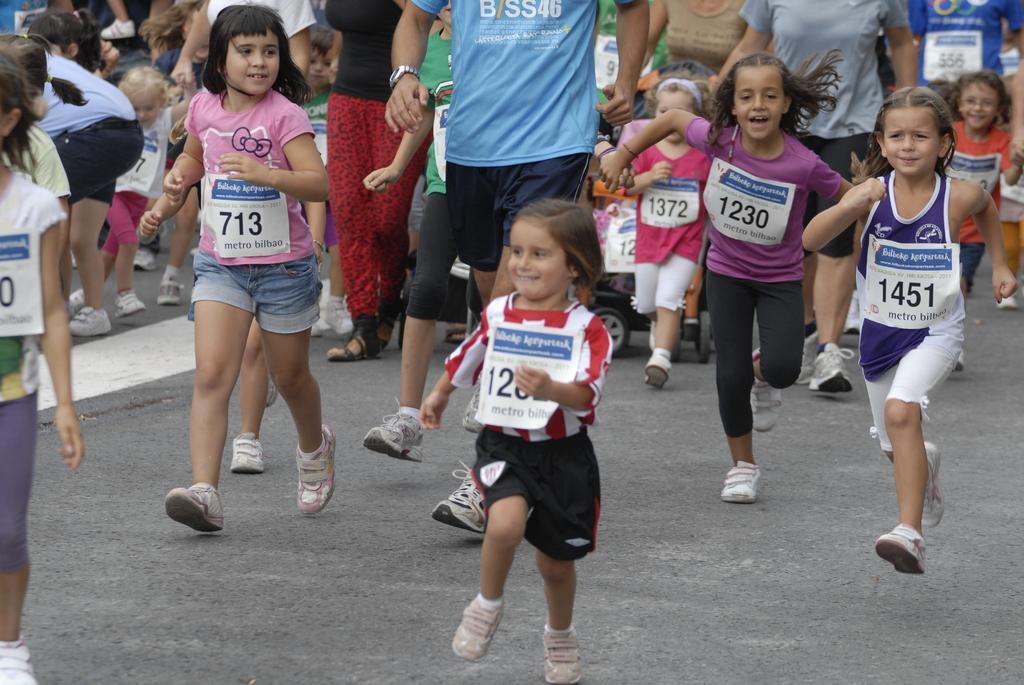Please provide a concise description of this image. In this picture, we see the children and the people are running on the road. In the middle, we see a baby stroller. At the bottom, we see the road. This picture might be clicked outside the city. 